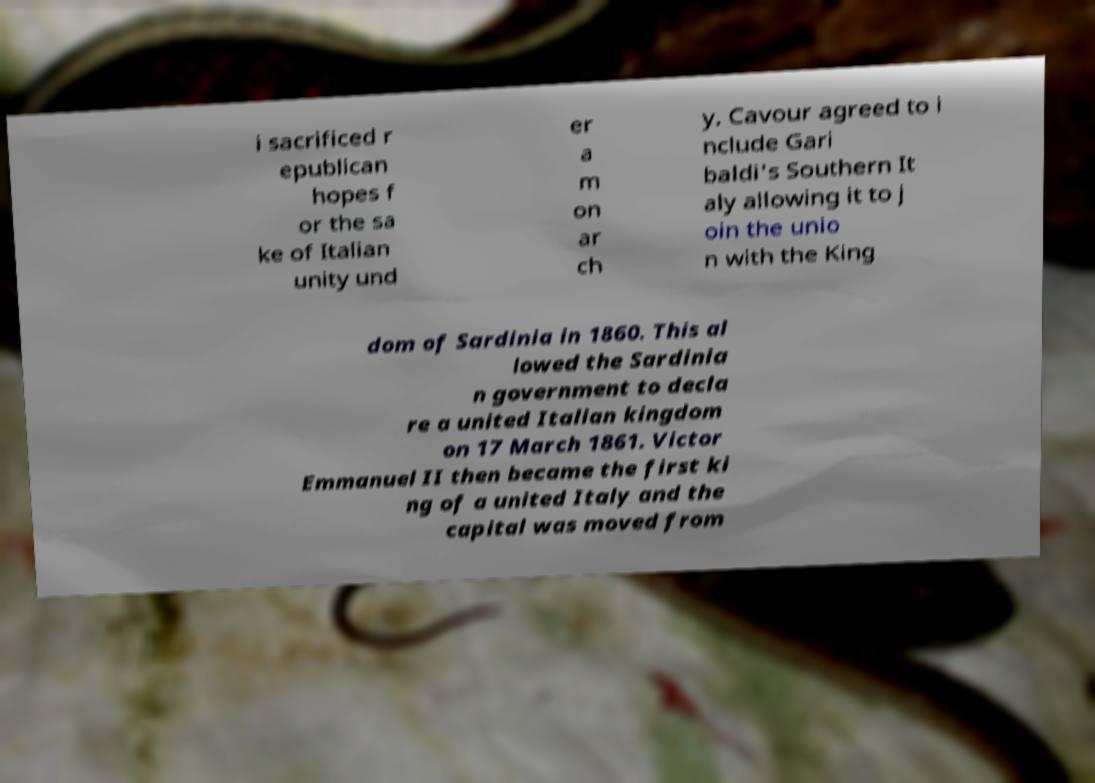Could you assist in decoding the text presented in this image and type it out clearly? i sacrificed r epublican hopes f or the sa ke of Italian unity und er a m on ar ch y. Cavour agreed to i nclude Gari baldi's Southern It aly allowing it to j oin the unio n with the King dom of Sardinia in 1860. This al lowed the Sardinia n government to decla re a united Italian kingdom on 17 March 1861. Victor Emmanuel II then became the first ki ng of a united Italy and the capital was moved from 